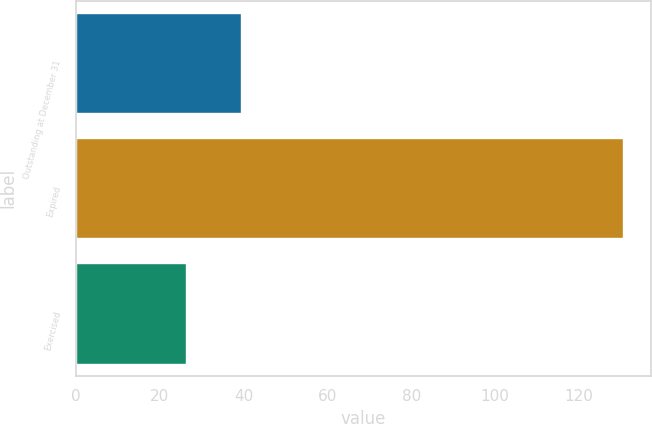Convert chart to OTSL. <chart><loc_0><loc_0><loc_500><loc_500><bar_chart><fcel>Outstanding at December 31<fcel>Expired<fcel>Exercised<nl><fcel>39.33<fcel>130.65<fcel>26.29<nl></chart> 